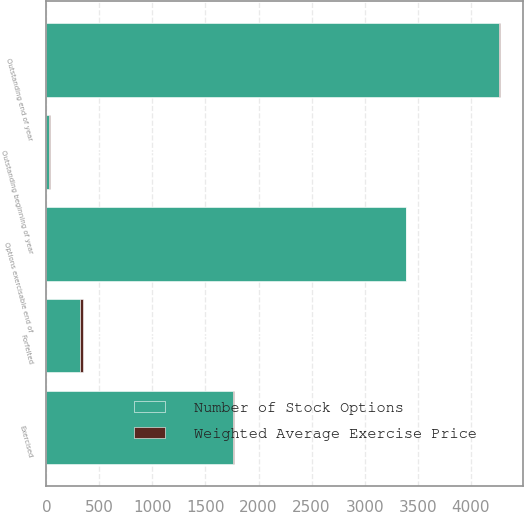Convert chart. <chart><loc_0><loc_0><loc_500><loc_500><stacked_bar_chart><ecel><fcel>Outstanding beginning of year<fcel>Exercised<fcel>Forfeited<fcel>Outstanding end of year<fcel>Options exercisable end of<nl><fcel>Number of Stock Options<fcel>26.26<fcel>1763<fcel>315<fcel>4265<fcel>3385<nl><fcel>Weighted Average Exercise Price<fcel>7.26<fcel>3.52<fcel>26.26<fcel>9.63<fcel>4.3<nl></chart> 